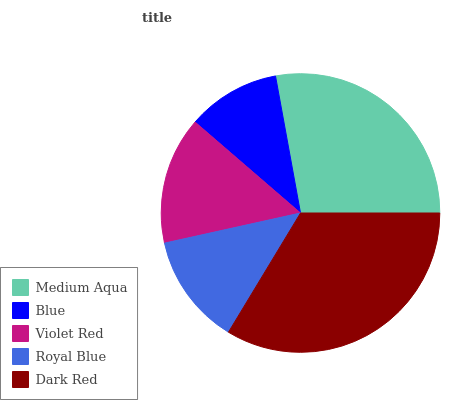Is Blue the minimum?
Answer yes or no. Yes. Is Dark Red the maximum?
Answer yes or no. Yes. Is Violet Red the minimum?
Answer yes or no. No. Is Violet Red the maximum?
Answer yes or no. No. Is Violet Red greater than Blue?
Answer yes or no. Yes. Is Blue less than Violet Red?
Answer yes or no. Yes. Is Blue greater than Violet Red?
Answer yes or no. No. Is Violet Red less than Blue?
Answer yes or no. No. Is Violet Red the high median?
Answer yes or no. Yes. Is Violet Red the low median?
Answer yes or no. Yes. Is Royal Blue the high median?
Answer yes or no. No. Is Medium Aqua the low median?
Answer yes or no. No. 